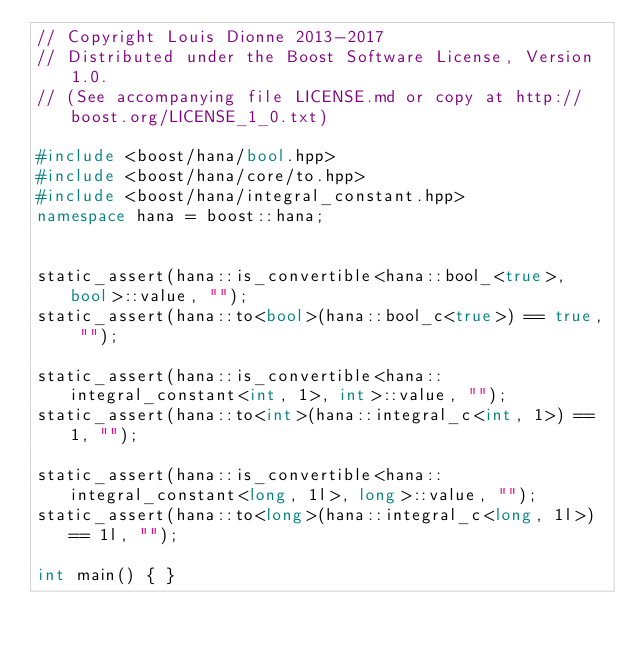<code> <loc_0><loc_0><loc_500><loc_500><_C++_>// Copyright Louis Dionne 2013-2017
// Distributed under the Boost Software License, Version 1.0.
// (See accompanying file LICENSE.md or copy at http://boost.org/LICENSE_1_0.txt)

#include <boost/hana/bool.hpp>
#include <boost/hana/core/to.hpp>
#include <boost/hana/integral_constant.hpp>
namespace hana = boost::hana;


static_assert(hana::is_convertible<hana::bool_<true>, bool>::value, "");
static_assert(hana::to<bool>(hana::bool_c<true>) == true, "");

static_assert(hana::is_convertible<hana::integral_constant<int, 1>, int>::value, "");
static_assert(hana::to<int>(hana::integral_c<int, 1>) == 1, "");

static_assert(hana::is_convertible<hana::integral_constant<long, 1l>, long>::value, "");
static_assert(hana::to<long>(hana::integral_c<long, 1l>) == 1l, "");

int main() { }
</code> 